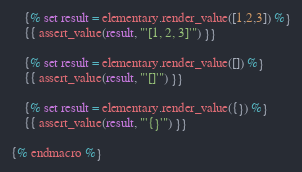<code> <loc_0><loc_0><loc_500><loc_500><_SQL_>
    {% set result = elementary.render_value([1,2,3]) %}
    {{ assert_value(result, "'[1, 2, 3]'") }}

    {% set result = elementary.render_value([]) %}
    {{ assert_value(result, "'[]'") }}

    {% set result = elementary.render_value({}) %}
    {{ assert_value(result, "'{}'") }}

{% endmacro %}</code> 